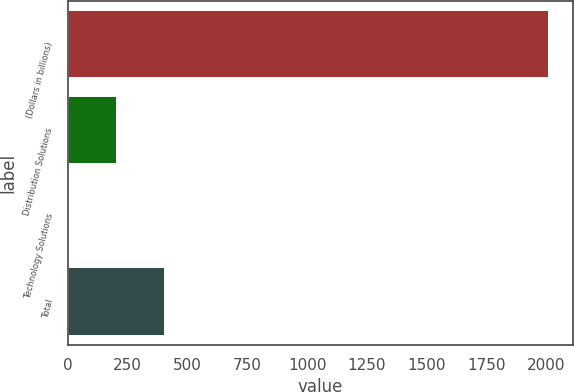Convert chart to OTSL. <chart><loc_0><loc_0><loc_500><loc_500><bar_chart><fcel>(Dollars in billions)<fcel>Distribution Solutions<fcel>Technology Solutions<fcel>Total<nl><fcel>2011<fcel>203.98<fcel>3.2<fcel>404.76<nl></chart> 